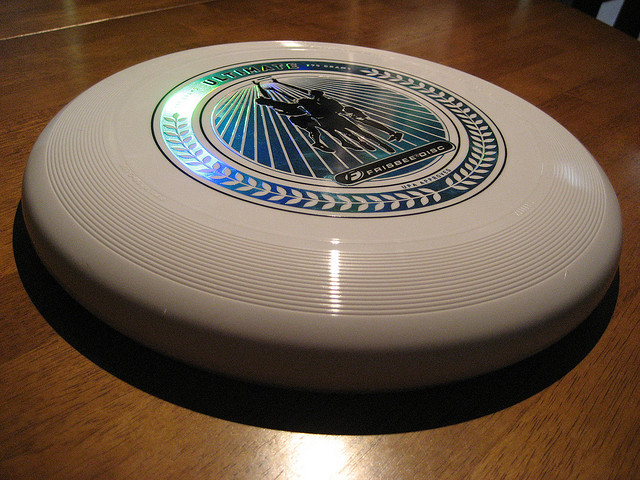<image>What team is this for? It is ambiguous what team this is for. It could be for 'guys', 'ultimate', 'frisbee', 'trojans', 'frisbee team'. What team is this for? It is ambiguous what team this is for. It can be both "ultimate" or "frisbee". 